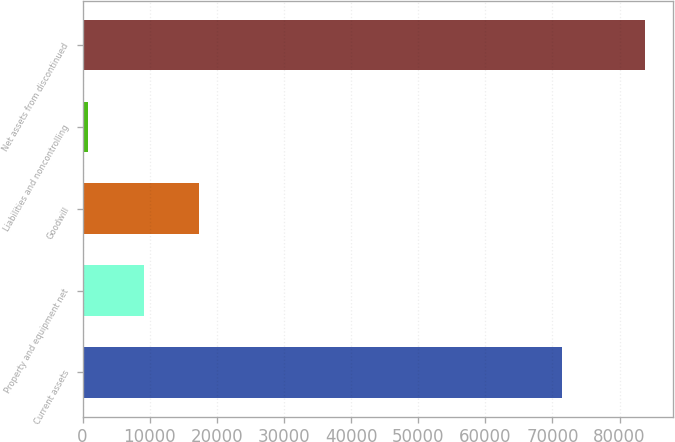<chart> <loc_0><loc_0><loc_500><loc_500><bar_chart><fcel>Current assets<fcel>Property and equipment net<fcel>Goodwill<fcel>Liabilities and noncontrolling<fcel>Net assets from discontinued<nl><fcel>71384<fcel>9125.4<fcel>17414.8<fcel>836<fcel>83730<nl></chart> 